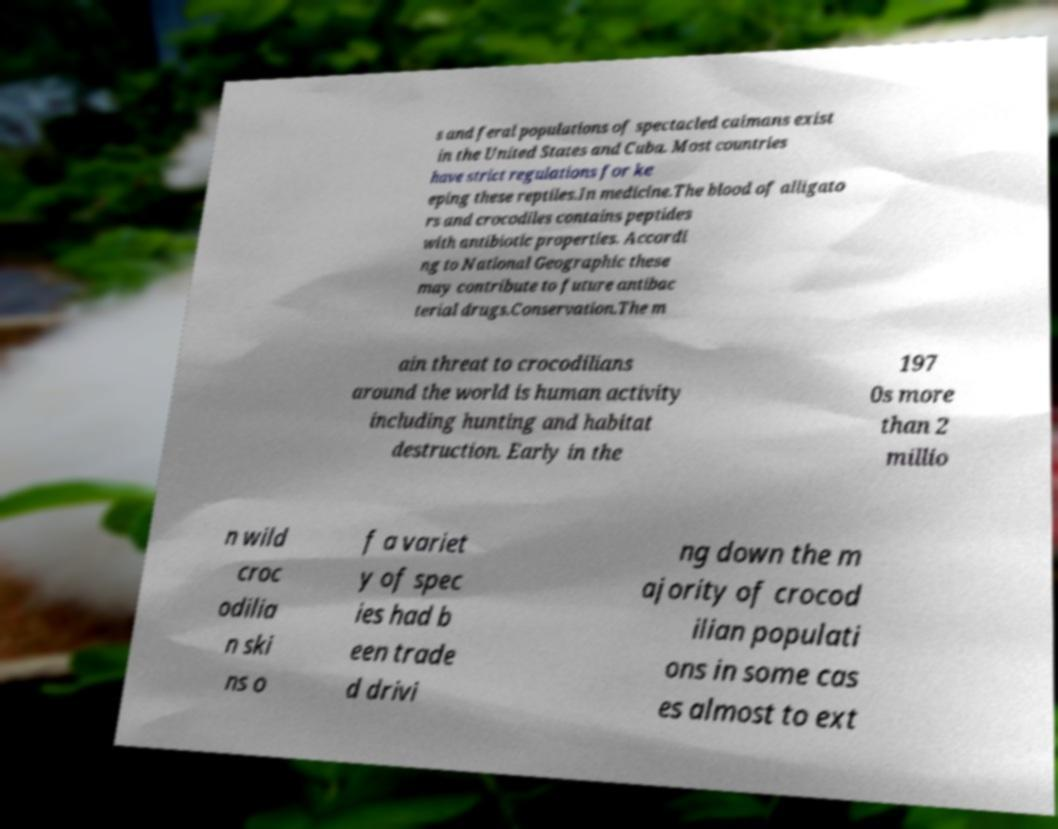I need the written content from this picture converted into text. Can you do that? s and feral populations of spectacled caimans exist in the United States and Cuba. Most countries have strict regulations for ke eping these reptiles.In medicine.The blood of alligato rs and crocodiles contains peptides with antibiotic properties. Accordi ng to National Geographic these may contribute to future antibac terial drugs.Conservation.The m ain threat to crocodilians around the world is human activity including hunting and habitat destruction. Early in the 197 0s more than 2 millio n wild croc odilia n ski ns o f a variet y of spec ies had b een trade d drivi ng down the m ajority of crocod ilian populati ons in some cas es almost to ext 